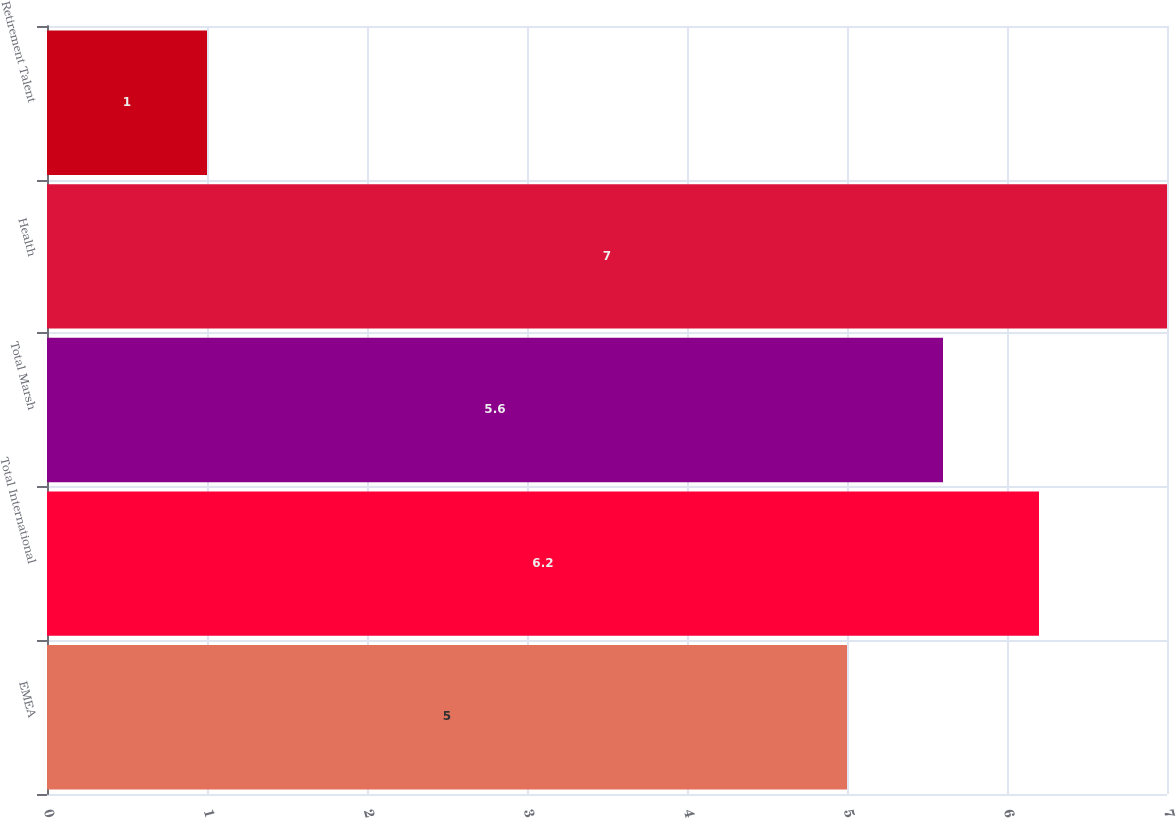Convert chart. <chart><loc_0><loc_0><loc_500><loc_500><bar_chart><fcel>EMEA<fcel>Total International<fcel>Total Marsh<fcel>Health<fcel>Retirement Talent<nl><fcel>5<fcel>6.2<fcel>5.6<fcel>7<fcel>1<nl></chart> 